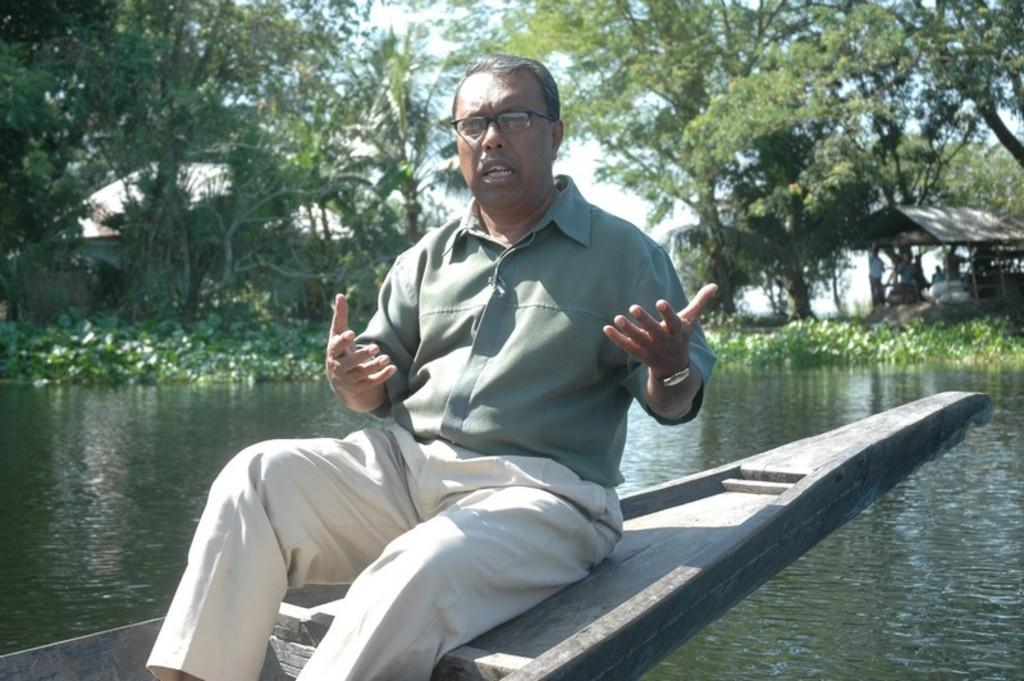What is the man in the image doing? The man is sitting on a boat in the image. What can be seen beneath the boat? There is water visible in the image. What is visible in the background of the image? There are people, plants, a shade, trees, the sky, and objects in the background of the image. Where is the playground located in the image? There is no playground present in the image. Is the image based on a fictional story? The image is not based on a fictional story; it appears to be a real-life scene. 